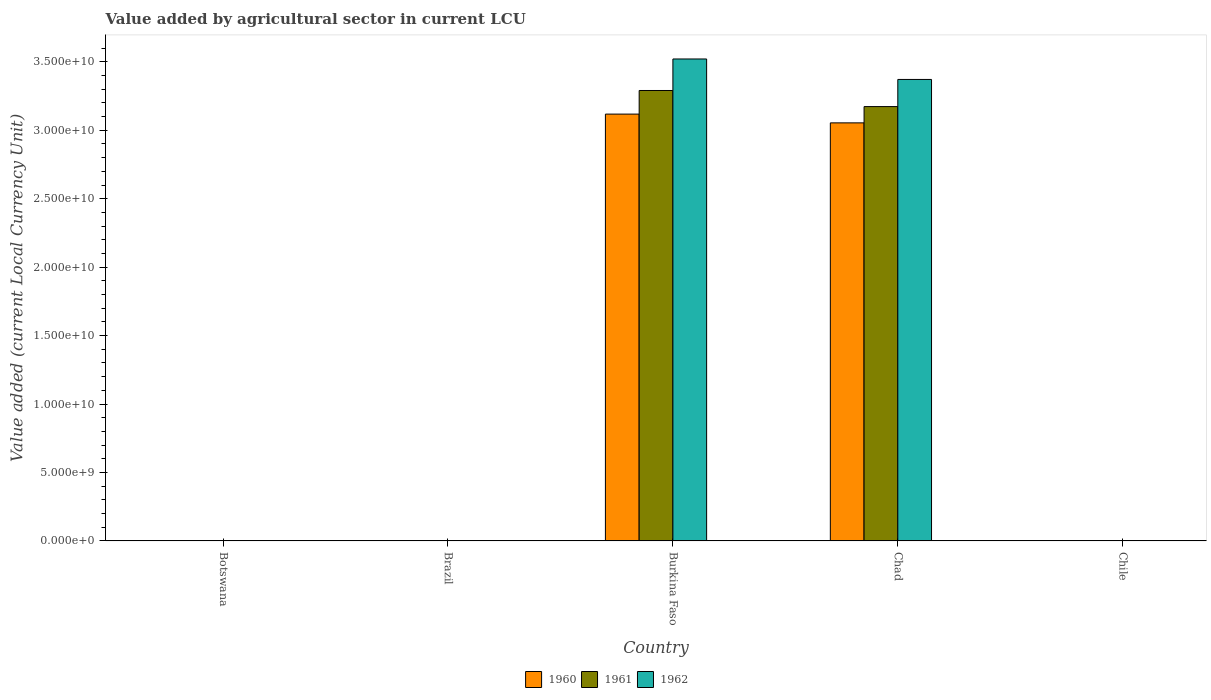How many different coloured bars are there?
Provide a succinct answer. 3. How many groups of bars are there?
Offer a terse response. 5. Are the number of bars on each tick of the X-axis equal?
Ensure brevity in your answer.  Yes. How many bars are there on the 1st tick from the left?
Keep it short and to the point. 3. What is the label of the 1st group of bars from the left?
Your answer should be compact. Botswana. What is the value added by agricultural sector in 1962 in Chad?
Keep it short and to the point. 3.37e+1. Across all countries, what is the maximum value added by agricultural sector in 1960?
Your response must be concise. 3.12e+1. Across all countries, what is the minimum value added by agricultural sector in 1960?
Offer a terse response. 0. In which country was the value added by agricultural sector in 1962 maximum?
Provide a succinct answer. Burkina Faso. In which country was the value added by agricultural sector in 1961 minimum?
Keep it short and to the point. Brazil. What is the total value added by agricultural sector in 1962 in the graph?
Offer a very short reply. 6.89e+1. What is the difference between the value added by agricultural sector in 1961 in Burkina Faso and that in Chad?
Offer a very short reply. 1.18e+09. What is the difference between the value added by agricultural sector in 1960 in Burkina Faso and the value added by agricultural sector in 1962 in Chad?
Your answer should be very brief. -2.53e+09. What is the average value added by agricultural sector in 1962 per country?
Provide a short and direct response. 1.38e+1. What is the difference between the value added by agricultural sector of/in 1961 and value added by agricultural sector of/in 1962 in Burkina Faso?
Offer a very short reply. -2.30e+09. What is the ratio of the value added by agricultural sector in 1961 in Burkina Faso to that in Chad?
Provide a succinct answer. 1.04. What is the difference between the highest and the second highest value added by agricultural sector in 1961?
Ensure brevity in your answer.  1.18e+09. What is the difference between the highest and the lowest value added by agricultural sector in 1962?
Make the answer very short. 3.52e+1. In how many countries, is the value added by agricultural sector in 1962 greater than the average value added by agricultural sector in 1962 taken over all countries?
Make the answer very short. 2. Is the sum of the value added by agricultural sector in 1960 in Botswana and Burkina Faso greater than the maximum value added by agricultural sector in 1962 across all countries?
Give a very brief answer. No. What does the 2nd bar from the right in Burkina Faso represents?
Your answer should be very brief. 1961. Are all the bars in the graph horizontal?
Give a very brief answer. No. Are the values on the major ticks of Y-axis written in scientific E-notation?
Provide a succinct answer. Yes. Does the graph contain grids?
Make the answer very short. No. Where does the legend appear in the graph?
Ensure brevity in your answer.  Bottom center. How many legend labels are there?
Ensure brevity in your answer.  3. How are the legend labels stacked?
Ensure brevity in your answer.  Horizontal. What is the title of the graph?
Your answer should be very brief. Value added by agricultural sector in current LCU. What is the label or title of the X-axis?
Offer a terse response. Country. What is the label or title of the Y-axis?
Give a very brief answer. Value added (current Local Currency Unit). What is the Value added (current Local Currency Unit) in 1960 in Botswana?
Your response must be concise. 9.38e+06. What is the Value added (current Local Currency Unit) in 1961 in Botswana?
Offer a terse response. 9.86e+06. What is the Value added (current Local Currency Unit) of 1962 in Botswana?
Your answer should be compact. 1.03e+07. What is the Value added (current Local Currency Unit) in 1960 in Brazil?
Keep it short and to the point. 0. What is the Value added (current Local Currency Unit) of 1961 in Brazil?
Provide a succinct answer. 0. What is the Value added (current Local Currency Unit) of 1962 in Brazil?
Keep it short and to the point. 0. What is the Value added (current Local Currency Unit) in 1960 in Burkina Faso?
Provide a succinct answer. 3.12e+1. What is the Value added (current Local Currency Unit) of 1961 in Burkina Faso?
Your answer should be very brief. 3.29e+1. What is the Value added (current Local Currency Unit) in 1962 in Burkina Faso?
Offer a terse response. 3.52e+1. What is the Value added (current Local Currency Unit) in 1960 in Chad?
Ensure brevity in your answer.  3.05e+1. What is the Value added (current Local Currency Unit) in 1961 in Chad?
Give a very brief answer. 3.17e+1. What is the Value added (current Local Currency Unit) in 1962 in Chad?
Keep it short and to the point. 3.37e+1. What is the Value added (current Local Currency Unit) of 1961 in Chile?
Provide a succinct answer. 5.00e+05. Across all countries, what is the maximum Value added (current Local Currency Unit) of 1960?
Keep it short and to the point. 3.12e+1. Across all countries, what is the maximum Value added (current Local Currency Unit) in 1961?
Your answer should be very brief. 3.29e+1. Across all countries, what is the maximum Value added (current Local Currency Unit) in 1962?
Your answer should be very brief. 3.52e+1. Across all countries, what is the minimum Value added (current Local Currency Unit) in 1960?
Your answer should be compact. 0. Across all countries, what is the minimum Value added (current Local Currency Unit) of 1961?
Keep it short and to the point. 0. Across all countries, what is the minimum Value added (current Local Currency Unit) of 1962?
Make the answer very short. 0. What is the total Value added (current Local Currency Unit) in 1960 in the graph?
Ensure brevity in your answer.  6.17e+1. What is the total Value added (current Local Currency Unit) in 1961 in the graph?
Your answer should be very brief. 6.46e+1. What is the total Value added (current Local Currency Unit) in 1962 in the graph?
Provide a succinct answer. 6.89e+1. What is the difference between the Value added (current Local Currency Unit) of 1960 in Botswana and that in Brazil?
Your response must be concise. 9.38e+06. What is the difference between the Value added (current Local Currency Unit) of 1961 in Botswana and that in Brazil?
Keep it short and to the point. 9.86e+06. What is the difference between the Value added (current Local Currency Unit) in 1962 in Botswana and that in Brazil?
Make the answer very short. 1.03e+07. What is the difference between the Value added (current Local Currency Unit) in 1960 in Botswana and that in Burkina Faso?
Ensure brevity in your answer.  -3.12e+1. What is the difference between the Value added (current Local Currency Unit) of 1961 in Botswana and that in Burkina Faso?
Your response must be concise. -3.29e+1. What is the difference between the Value added (current Local Currency Unit) in 1962 in Botswana and that in Burkina Faso?
Keep it short and to the point. -3.52e+1. What is the difference between the Value added (current Local Currency Unit) in 1960 in Botswana and that in Chad?
Your response must be concise. -3.05e+1. What is the difference between the Value added (current Local Currency Unit) in 1961 in Botswana and that in Chad?
Give a very brief answer. -3.17e+1. What is the difference between the Value added (current Local Currency Unit) in 1962 in Botswana and that in Chad?
Ensure brevity in your answer.  -3.37e+1. What is the difference between the Value added (current Local Currency Unit) in 1960 in Botswana and that in Chile?
Keep it short and to the point. 8.98e+06. What is the difference between the Value added (current Local Currency Unit) of 1961 in Botswana and that in Chile?
Provide a short and direct response. 9.36e+06. What is the difference between the Value added (current Local Currency Unit) in 1962 in Botswana and that in Chile?
Your answer should be compact. 9.84e+06. What is the difference between the Value added (current Local Currency Unit) in 1960 in Brazil and that in Burkina Faso?
Make the answer very short. -3.12e+1. What is the difference between the Value added (current Local Currency Unit) of 1961 in Brazil and that in Burkina Faso?
Give a very brief answer. -3.29e+1. What is the difference between the Value added (current Local Currency Unit) in 1962 in Brazil and that in Burkina Faso?
Provide a succinct answer. -3.52e+1. What is the difference between the Value added (current Local Currency Unit) in 1960 in Brazil and that in Chad?
Keep it short and to the point. -3.05e+1. What is the difference between the Value added (current Local Currency Unit) in 1961 in Brazil and that in Chad?
Provide a short and direct response. -3.17e+1. What is the difference between the Value added (current Local Currency Unit) in 1962 in Brazil and that in Chad?
Provide a succinct answer. -3.37e+1. What is the difference between the Value added (current Local Currency Unit) in 1960 in Brazil and that in Chile?
Your answer should be compact. -4.00e+05. What is the difference between the Value added (current Local Currency Unit) of 1961 in Brazil and that in Chile?
Give a very brief answer. -5.00e+05. What is the difference between the Value added (current Local Currency Unit) in 1962 in Brazil and that in Chile?
Make the answer very short. -5.00e+05. What is the difference between the Value added (current Local Currency Unit) in 1960 in Burkina Faso and that in Chad?
Your answer should be very brief. 6.41e+08. What is the difference between the Value added (current Local Currency Unit) of 1961 in Burkina Faso and that in Chad?
Your answer should be compact. 1.18e+09. What is the difference between the Value added (current Local Currency Unit) of 1962 in Burkina Faso and that in Chad?
Your answer should be compact. 1.50e+09. What is the difference between the Value added (current Local Currency Unit) of 1960 in Burkina Faso and that in Chile?
Ensure brevity in your answer.  3.12e+1. What is the difference between the Value added (current Local Currency Unit) of 1961 in Burkina Faso and that in Chile?
Your answer should be compact. 3.29e+1. What is the difference between the Value added (current Local Currency Unit) of 1962 in Burkina Faso and that in Chile?
Give a very brief answer. 3.52e+1. What is the difference between the Value added (current Local Currency Unit) of 1960 in Chad and that in Chile?
Provide a short and direct response. 3.05e+1. What is the difference between the Value added (current Local Currency Unit) in 1961 in Chad and that in Chile?
Your answer should be very brief. 3.17e+1. What is the difference between the Value added (current Local Currency Unit) of 1962 in Chad and that in Chile?
Offer a very short reply. 3.37e+1. What is the difference between the Value added (current Local Currency Unit) of 1960 in Botswana and the Value added (current Local Currency Unit) of 1961 in Brazil?
Give a very brief answer. 9.38e+06. What is the difference between the Value added (current Local Currency Unit) of 1960 in Botswana and the Value added (current Local Currency Unit) of 1962 in Brazil?
Keep it short and to the point. 9.38e+06. What is the difference between the Value added (current Local Currency Unit) in 1961 in Botswana and the Value added (current Local Currency Unit) in 1962 in Brazil?
Your answer should be compact. 9.86e+06. What is the difference between the Value added (current Local Currency Unit) in 1960 in Botswana and the Value added (current Local Currency Unit) in 1961 in Burkina Faso?
Provide a succinct answer. -3.29e+1. What is the difference between the Value added (current Local Currency Unit) of 1960 in Botswana and the Value added (current Local Currency Unit) of 1962 in Burkina Faso?
Your answer should be very brief. -3.52e+1. What is the difference between the Value added (current Local Currency Unit) of 1961 in Botswana and the Value added (current Local Currency Unit) of 1962 in Burkina Faso?
Provide a short and direct response. -3.52e+1. What is the difference between the Value added (current Local Currency Unit) in 1960 in Botswana and the Value added (current Local Currency Unit) in 1961 in Chad?
Offer a terse response. -3.17e+1. What is the difference between the Value added (current Local Currency Unit) of 1960 in Botswana and the Value added (current Local Currency Unit) of 1962 in Chad?
Your answer should be very brief. -3.37e+1. What is the difference between the Value added (current Local Currency Unit) of 1961 in Botswana and the Value added (current Local Currency Unit) of 1962 in Chad?
Your answer should be very brief. -3.37e+1. What is the difference between the Value added (current Local Currency Unit) of 1960 in Botswana and the Value added (current Local Currency Unit) of 1961 in Chile?
Provide a succinct answer. 8.88e+06. What is the difference between the Value added (current Local Currency Unit) of 1960 in Botswana and the Value added (current Local Currency Unit) of 1962 in Chile?
Provide a succinct answer. 8.88e+06. What is the difference between the Value added (current Local Currency Unit) of 1961 in Botswana and the Value added (current Local Currency Unit) of 1962 in Chile?
Keep it short and to the point. 9.36e+06. What is the difference between the Value added (current Local Currency Unit) in 1960 in Brazil and the Value added (current Local Currency Unit) in 1961 in Burkina Faso?
Keep it short and to the point. -3.29e+1. What is the difference between the Value added (current Local Currency Unit) in 1960 in Brazil and the Value added (current Local Currency Unit) in 1962 in Burkina Faso?
Offer a very short reply. -3.52e+1. What is the difference between the Value added (current Local Currency Unit) of 1961 in Brazil and the Value added (current Local Currency Unit) of 1962 in Burkina Faso?
Keep it short and to the point. -3.52e+1. What is the difference between the Value added (current Local Currency Unit) in 1960 in Brazil and the Value added (current Local Currency Unit) in 1961 in Chad?
Make the answer very short. -3.17e+1. What is the difference between the Value added (current Local Currency Unit) in 1960 in Brazil and the Value added (current Local Currency Unit) in 1962 in Chad?
Offer a very short reply. -3.37e+1. What is the difference between the Value added (current Local Currency Unit) in 1961 in Brazil and the Value added (current Local Currency Unit) in 1962 in Chad?
Keep it short and to the point. -3.37e+1. What is the difference between the Value added (current Local Currency Unit) of 1960 in Brazil and the Value added (current Local Currency Unit) of 1961 in Chile?
Make the answer very short. -5.00e+05. What is the difference between the Value added (current Local Currency Unit) of 1960 in Brazil and the Value added (current Local Currency Unit) of 1962 in Chile?
Offer a very short reply. -5.00e+05. What is the difference between the Value added (current Local Currency Unit) in 1961 in Brazil and the Value added (current Local Currency Unit) in 1962 in Chile?
Give a very brief answer. -5.00e+05. What is the difference between the Value added (current Local Currency Unit) in 1960 in Burkina Faso and the Value added (current Local Currency Unit) in 1961 in Chad?
Your answer should be compact. -5.49e+08. What is the difference between the Value added (current Local Currency Unit) in 1960 in Burkina Faso and the Value added (current Local Currency Unit) in 1962 in Chad?
Your answer should be compact. -2.53e+09. What is the difference between the Value added (current Local Currency Unit) of 1961 in Burkina Faso and the Value added (current Local Currency Unit) of 1962 in Chad?
Provide a succinct answer. -8.07e+08. What is the difference between the Value added (current Local Currency Unit) of 1960 in Burkina Faso and the Value added (current Local Currency Unit) of 1961 in Chile?
Offer a terse response. 3.12e+1. What is the difference between the Value added (current Local Currency Unit) in 1960 in Burkina Faso and the Value added (current Local Currency Unit) in 1962 in Chile?
Your response must be concise. 3.12e+1. What is the difference between the Value added (current Local Currency Unit) of 1961 in Burkina Faso and the Value added (current Local Currency Unit) of 1962 in Chile?
Offer a terse response. 3.29e+1. What is the difference between the Value added (current Local Currency Unit) of 1960 in Chad and the Value added (current Local Currency Unit) of 1961 in Chile?
Your answer should be compact. 3.05e+1. What is the difference between the Value added (current Local Currency Unit) in 1960 in Chad and the Value added (current Local Currency Unit) in 1962 in Chile?
Your answer should be very brief. 3.05e+1. What is the difference between the Value added (current Local Currency Unit) in 1961 in Chad and the Value added (current Local Currency Unit) in 1962 in Chile?
Your answer should be compact. 3.17e+1. What is the average Value added (current Local Currency Unit) of 1960 per country?
Provide a short and direct response. 1.23e+1. What is the average Value added (current Local Currency Unit) in 1961 per country?
Your answer should be very brief. 1.29e+1. What is the average Value added (current Local Currency Unit) of 1962 per country?
Provide a short and direct response. 1.38e+1. What is the difference between the Value added (current Local Currency Unit) of 1960 and Value added (current Local Currency Unit) of 1961 in Botswana?
Provide a succinct answer. -4.83e+05. What is the difference between the Value added (current Local Currency Unit) in 1960 and Value added (current Local Currency Unit) in 1962 in Botswana?
Your answer should be very brief. -9.65e+05. What is the difference between the Value added (current Local Currency Unit) of 1961 and Value added (current Local Currency Unit) of 1962 in Botswana?
Offer a terse response. -4.83e+05. What is the difference between the Value added (current Local Currency Unit) of 1960 and Value added (current Local Currency Unit) of 1961 in Brazil?
Make the answer very short. -0. What is the difference between the Value added (current Local Currency Unit) in 1960 and Value added (current Local Currency Unit) in 1962 in Brazil?
Your response must be concise. -0. What is the difference between the Value added (current Local Currency Unit) in 1961 and Value added (current Local Currency Unit) in 1962 in Brazil?
Your answer should be very brief. -0. What is the difference between the Value added (current Local Currency Unit) in 1960 and Value added (current Local Currency Unit) in 1961 in Burkina Faso?
Offer a terse response. -1.73e+09. What is the difference between the Value added (current Local Currency Unit) of 1960 and Value added (current Local Currency Unit) of 1962 in Burkina Faso?
Offer a terse response. -4.03e+09. What is the difference between the Value added (current Local Currency Unit) of 1961 and Value added (current Local Currency Unit) of 1962 in Burkina Faso?
Keep it short and to the point. -2.30e+09. What is the difference between the Value added (current Local Currency Unit) in 1960 and Value added (current Local Currency Unit) in 1961 in Chad?
Your answer should be compact. -1.19e+09. What is the difference between the Value added (current Local Currency Unit) in 1960 and Value added (current Local Currency Unit) in 1962 in Chad?
Offer a terse response. -3.17e+09. What is the difference between the Value added (current Local Currency Unit) of 1961 and Value added (current Local Currency Unit) of 1962 in Chad?
Keep it short and to the point. -1.98e+09. What is the difference between the Value added (current Local Currency Unit) in 1960 and Value added (current Local Currency Unit) in 1961 in Chile?
Ensure brevity in your answer.  -1.00e+05. What is the ratio of the Value added (current Local Currency Unit) of 1960 in Botswana to that in Brazil?
Provide a short and direct response. 5.15e+1. What is the ratio of the Value added (current Local Currency Unit) of 1961 in Botswana to that in Brazil?
Your answer should be very brief. 3.86e+1. What is the ratio of the Value added (current Local Currency Unit) of 1962 in Botswana to that in Brazil?
Your response must be concise. 2.37e+1. What is the ratio of the Value added (current Local Currency Unit) in 1960 in Botswana to that in Chad?
Keep it short and to the point. 0. What is the ratio of the Value added (current Local Currency Unit) of 1960 in Botswana to that in Chile?
Your answer should be very brief. 23.44. What is the ratio of the Value added (current Local Currency Unit) of 1961 in Botswana to that in Chile?
Give a very brief answer. 19.72. What is the ratio of the Value added (current Local Currency Unit) in 1962 in Botswana to that in Chile?
Your answer should be very brief. 20.68. What is the ratio of the Value added (current Local Currency Unit) in 1962 in Brazil to that in Burkina Faso?
Your answer should be compact. 0. What is the ratio of the Value added (current Local Currency Unit) in 1960 in Brazil to that in Chad?
Provide a short and direct response. 0. What is the ratio of the Value added (current Local Currency Unit) in 1961 in Brazil to that in Chad?
Make the answer very short. 0. What is the ratio of the Value added (current Local Currency Unit) of 1961 in Brazil to that in Chile?
Ensure brevity in your answer.  0. What is the ratio of the Value added (current Local Currency Unit) of 1962 in Brazil to that in Chile?
Ensure brevity in your answer.  0. What is the ratio of the Value added (current Local Currency Unit) of 1961 in Burkina Faso to that in Chad?
Ensure brevity in your answer.  1.04. What is the ratio of the Value added (current Local Currency Unit) in 1962 in Burkina Faso to that in Chad?
Offer a terse response. 1.04. What is the ratio of the Value added (current Local Currency Unit) of 1960 in Burkina Faso to that in Chile?
Your response must be concise. 7.80e+04. What is the ratio of the Value added (current Local Currency Unit) in 1961 in Burkina Faso to that in Chile?
Ensure brevity in your answer.  6.58e+04. What is the ratio of the Value added (current Local Currency Unit) in 1962 in Burkina Faso to that in Chile?
Keep it short and to the point. 7.04e+04. What is the ratio of the Value added (current Local Currency Unit) of 1960 in Chad to that in Chile?
Keep it short and to the point. 7.64e+04. What is the ratio of the Value added (current Local Currency Unit) of 1961 in Chad to that in Chile?
Give a very brief answer. 6.35e+04. What is the ratio of the Value added (current Local Currency Unit) in 1962 in Chad to that in Chile?
Offer a terse response. 6.74e+04. What is the difference between the highest and the second highest Value added (current Local Currency Unit) of 1960?
Provide a succinct answer. 6.41e+08. What is the difference between the highest and the second highest Value added (current Local Currency Unit) in 1961?
Offer a terse response. 1.18e+09. What is the difference between the highest and the second highest Value added (current Local Currency Unit) of 1962?
Ensure brevity in your answer.  1.50e+09. What is the difference between the highest and the lowest Value added (current Local Currency Unit) of 1960?
Your response must be concise. 3.12e+1. What is the difference between the highest and the lowest Value added (current Local Currency Unit) of 1961?
Make the answer very short. 3.29e+1. What is the difference between the highest and the lowest Value added (current Local Currency Unit) of 1962?
Keep it short and to the point. 3.52e+1. 